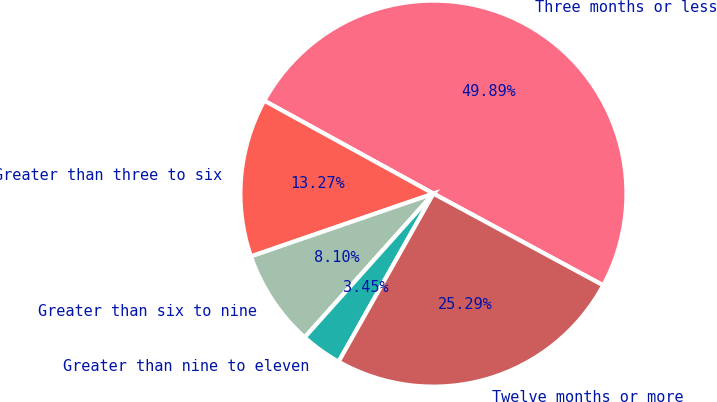Convert chart to OTSL. <chart><loc_0><loc_0><loc_500><loc_500><pie_chart><fcel>Three months or less<fcel>Greater than three to six<fcel>Greater than six to nine<fcel>Greater than nine to eleven<fcel>Twelve months or more<nl><fcel>49.89%<fcel>13.27%<fcel>8.1%<fcel>3.45%<fcel>25.29%<nl></chart> 